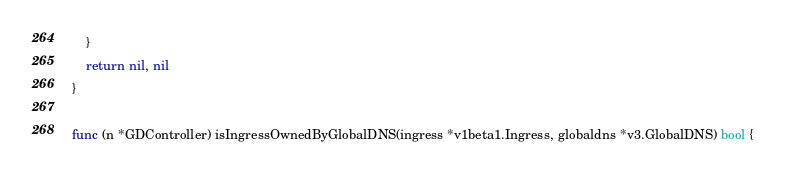<code> <loc_0><loc_0><loc_500><loc_500><_Go_>	}
	return nil, nil
}

func (n *GDController) isIngressOwnedByGlobalDNS(ingress *v1beta1.Ingress, globaldns *v3.GlobalDNS) bool {</code> 